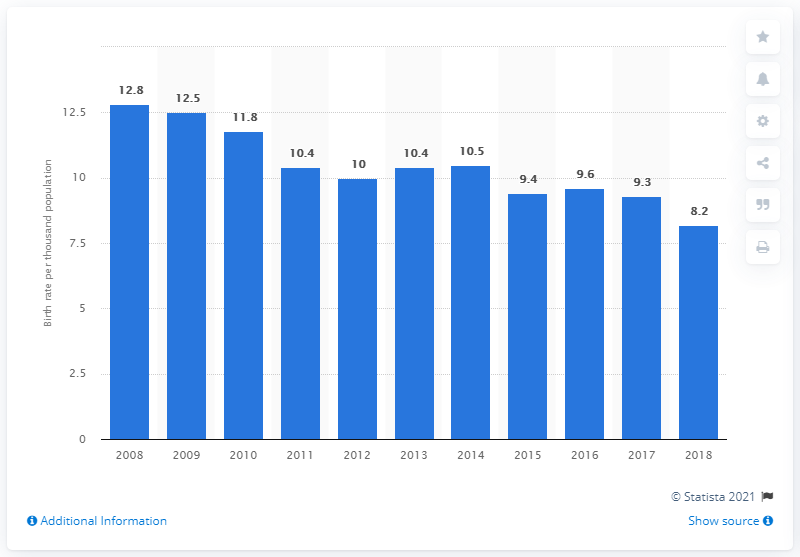Specify some key components in this picture. The crude birth rate in Bermuda in 2018 was 8.2. 